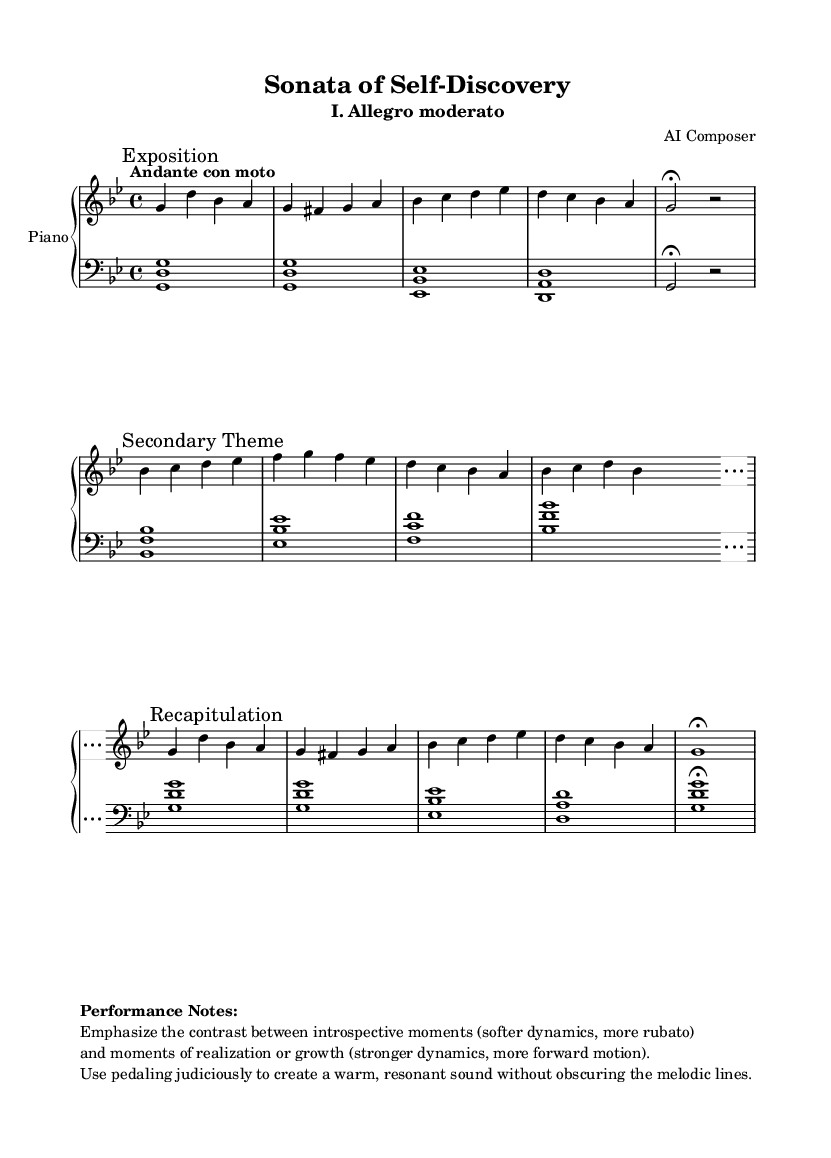What is the key signature of this music? The key signature is indicated at the beginning of the piece. It shows two flats, which corresponds to B flat and E flat. Thus, the key signature is B flat major or G minor.
Answer: G minor What is the time signature of this music? The time signature is shown at the beginning of the piece with a 4 over 4, indicating four beats per measure and a quarter note receives a beat.
Answer: 4/4 What is the tempo marking for this piece? The tempo marking is clearly noted at the start and describes the desired speed of the piece. It indicates "Andante con moto," suggesting a moderately slow tempo with a bit of movement.
Answer: Andante con moto How many sections does this sonata have? Sections are marked within the music, labeled as "Exposition," "Secondary Theme," "Development," and "Recapitulation." Counting these provides the total number of sections.
Answer: Four sections What dynamic contrast is suggested in the performance notes? The performance notes emphasize the need for a contrast between softer dynamics during introspective moments and stronger dynamics during moments of realization or growth, indicating how to convey emotion through dynamics.
Answer: Soft and strong dynamics What instrument is this score intended for? The title at the beginning includes the instrumentation and indicates that this music is specifically written for piano.
Answer: Piano In which part of the piece is the Development section located? The score uses marks to clearly delineate the sections, with "Development" mentioned after the "Secondary Theme," so locating this section relies on those labeled markers.
Answer: After the Secondary Theme 